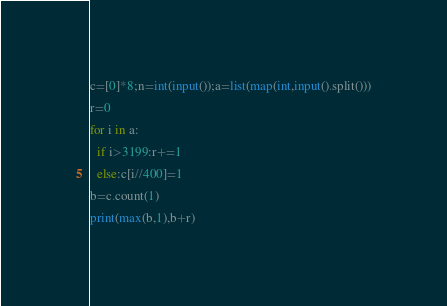Convert code to text. <code><loc_0><loc_0><loc_500><loc_500><_Python_>c=[0]*8;n=int(input());a=list(map(int,input().split()))
r=0
for i in a:
  if i>3199:r+=1
  else:c[i//400]=1
b=c.count(1)
print(max(b,1),b+r)</code> 